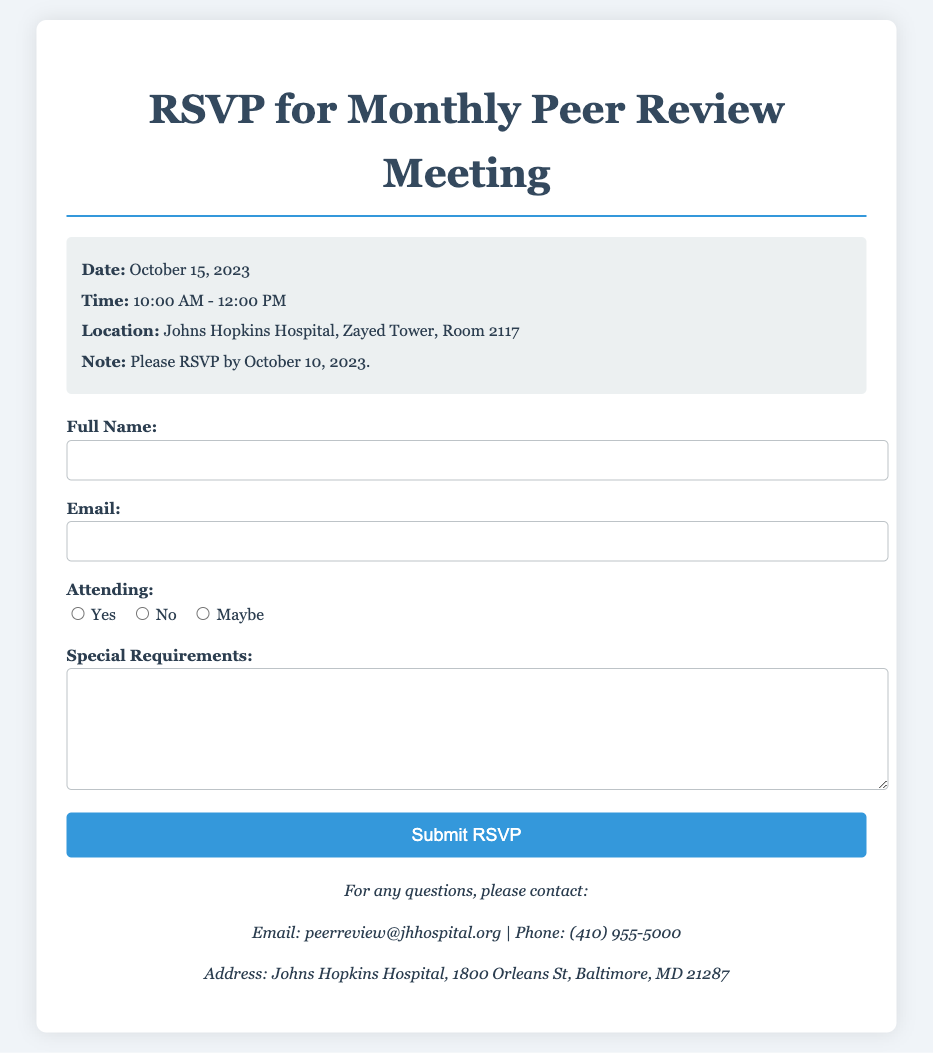What is the date of the meeting? The date of the meeting is explicitly mentioned in the document.
Answer: October 15, 2023 What time does the meeting start? The starting time of the meeting is provided in the meeting information section.
Answer: 10:00 AM Where is the meeting located? The location of the meeting is specified in the document.
Answer: Johns Hopkins Hospital, Zayed Tower, Room 2117 What is the RSVP deadline? The document states the deadline for RSVPs clearly.
Answer: October 10, 2023 What email should be used for inquiries? The document lists the contact email for any questions related to the meeting.
Answer: peerreview@jhhospital.org If someone cannot attend, which option should they select? The document indicates the response options for attendance in the RSVP form.
Answer: No How many response options are provided for attendees? The number of response options can be counted directly from the document.
Answer: Three What should be included in the "Special Requirements" section? The "Special Requirements" section is intended for additional information.
Answer: Special requirements What organization is hosting the meeting? The hosting organization can be identified from the contact information provided.
Answer: Johns Hopkins Hospital 